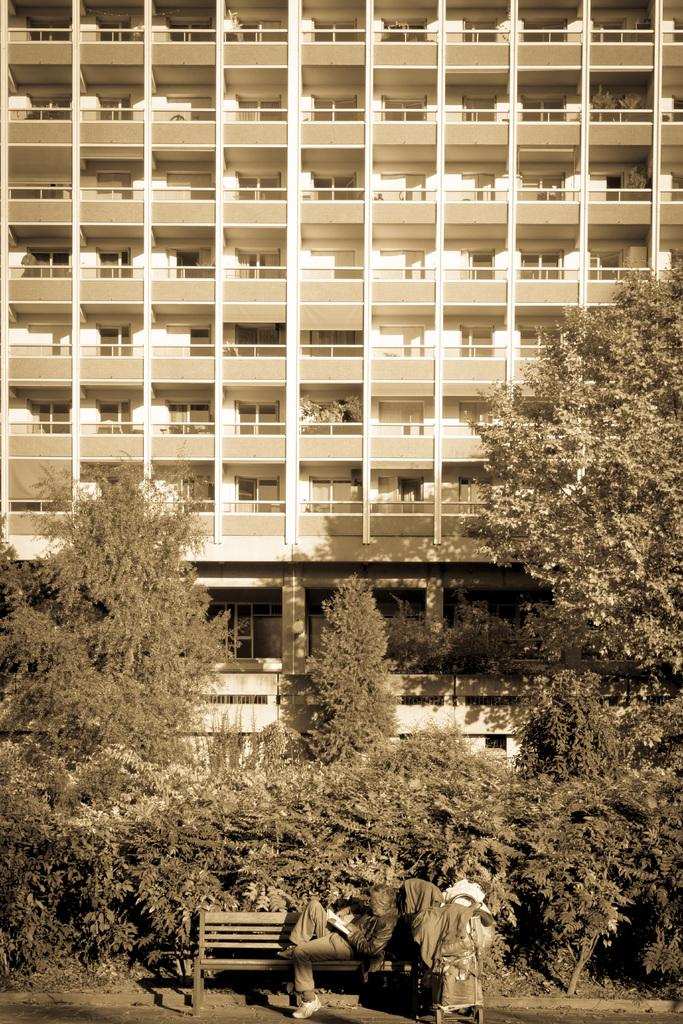What is the person in the image doing? There is a person sitting on a bench in the image. What is located near the person? There is luggage beside the person. What can be seen in the background of the image? There are trees and a building in the background of the image. What type of rice is being cooked in the background of the image? There is no rice present in the image; it only features a person sitting on a bench, luggage, trees, and a building in the background. 